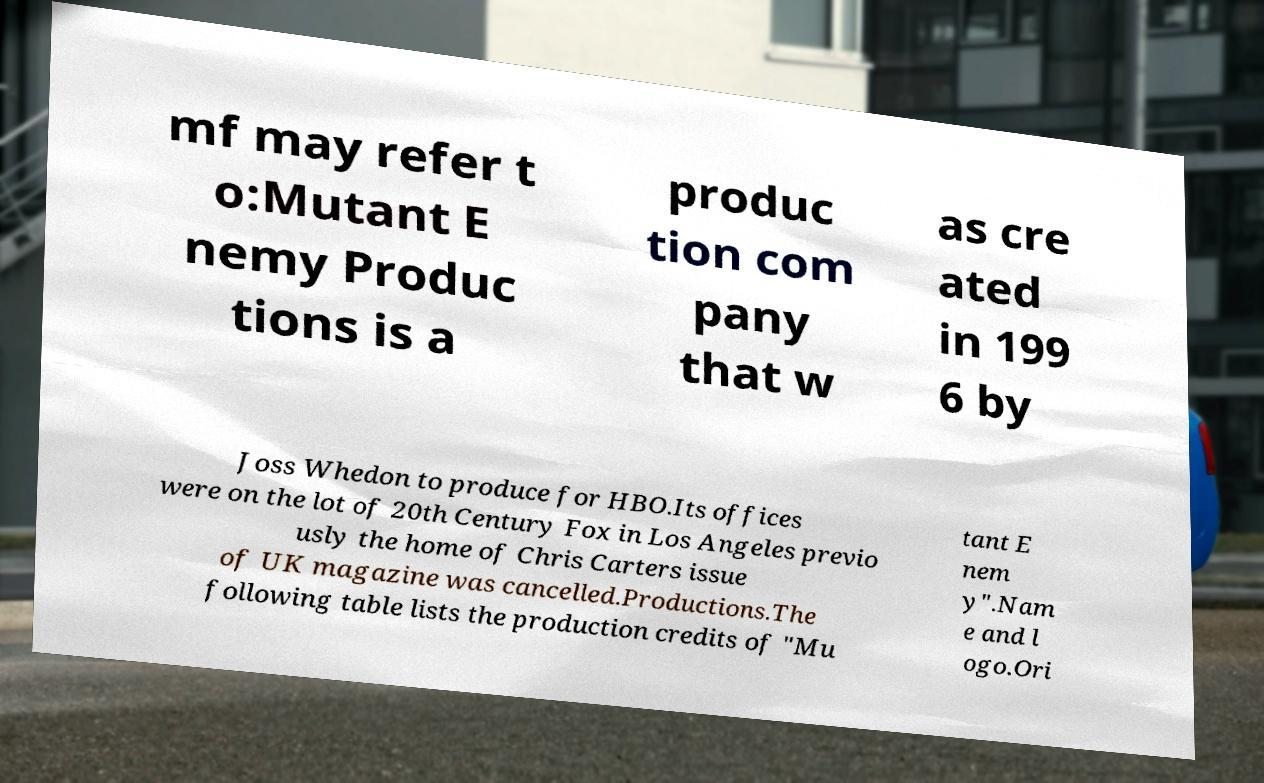What messages or text are displayed in this image? I need them in a readable, typed format. mf may refer t o:Mutant E nemy Produc tions is a produc tion com pany that w as cre ated in 199 6 by Joss Whedon to produce for HBO.Its offices were on the lot of 20th Century Fox in Los Angeles previo usly the home of Chris Carters issue of UK magazine was cancelled.Productions.The following table lists the production credits of "Mu tant E nem y".Nam e and l ogo.Ori 